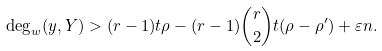Convert formula to latex. <formula><loc_0><loc_0><loc_500><loc_500>\deg _ { w } ( y , Y ) > ( r - 1 ) t \rho - ( r - 1 ) { r \choose 2 } t ( \rho - \rho ^ { \prime } ) + \varepsilon n .</formula> 